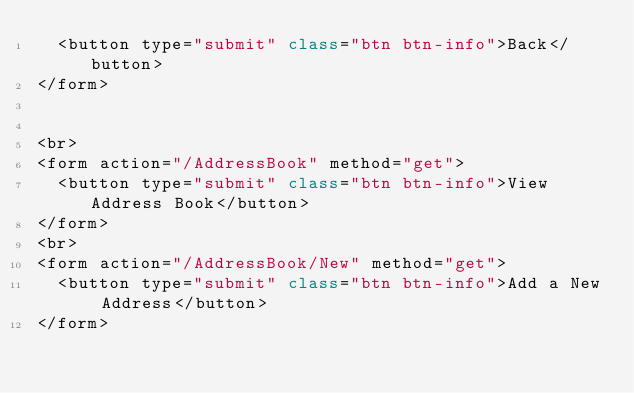<code> <loc_0><loc_0><loc_500><loc_500><_C#_>  <button type="submit" class="btn btn-info">Back</button>
</form>


<br>
<form action="/AddressBook" method="get">
  <button type="submit" class="btn btn-info">View Address Book</button>
</form>
<br>
<form action="/AddressBook/New" method="get">
  <button type="submit" class="btn btn-info">Add a New Address</button>
</form>
</code> 